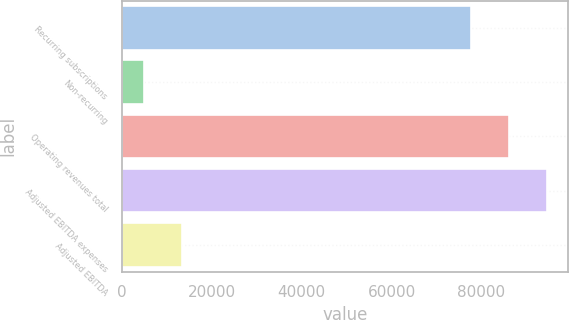Convert chart. <chart><loc_0><loc_0><loc_500><loc_500><bar_chart><fcel>Recurring subscriptions<fcel>Non-recurring<fcel>Operating revenues total<fcel>Adjusted EBITDA expenses<fcel>Adjusted EBITDA<nl><fcel>77666<fcel>4959<fcel>86108.4<fcel>94550.8<fcel>13401.4<nl></chart> 